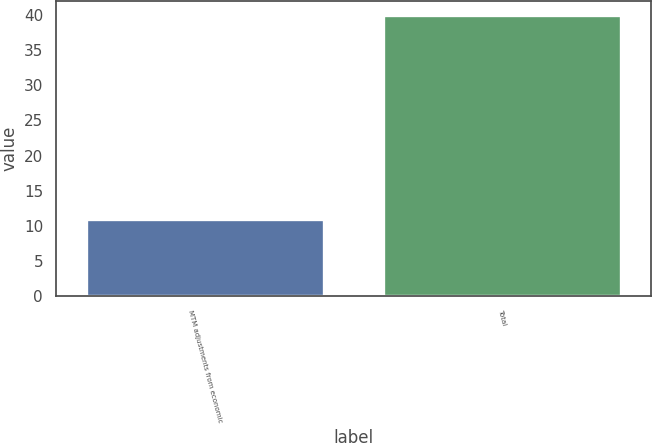Convert chart to OTSL. <chart><loc_0><loc_0><loc_500><loc_500><bar_chart><fcel>MTM adjustments from economic<fcel>Total<nl><fcel>11<fcel>40<nl></chart> 